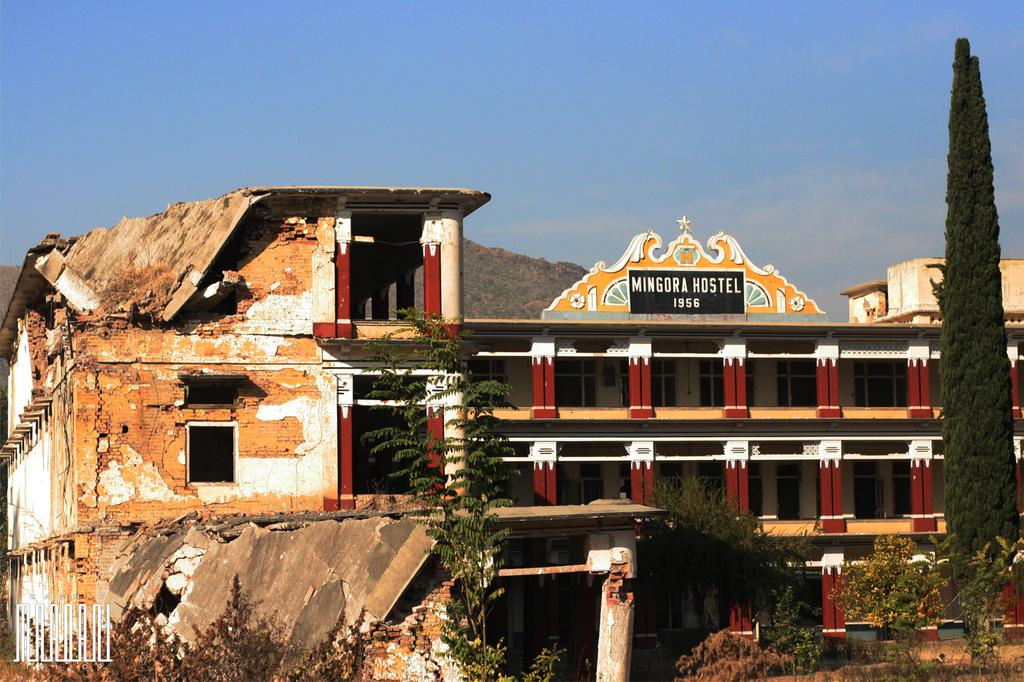What type of structure is present in the image? There is a building in the image. What feature can be seen on the building? The building has windows. What type of vegetation is present in the image? There are trees, plants, and bushes in the image. What is visible in the background of the image? The sky is visible in the image. What is written or displayed on the board in the image? There is a board with text in the image. How do the pigs contribute to the acoustics of the building in the image? There are no pigs present in the image, so their contribution to the acoustics cannot be determined. 